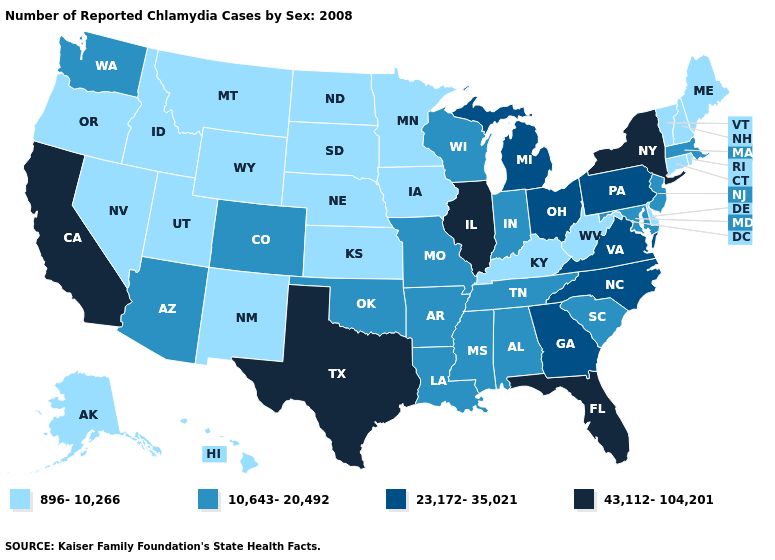What is the value of Nebraska?
Short answer required. 896-10,266. Among the states that border Louisiana , which have the highest value?
Write a very short answer. Texas. Name the states that have a value in the range 43,112-104,201?
Give a very brief answer. California, Florida, Illinois, New York, Texas. Is the legend a continuous bar?
Answer briefly. No. Among the states that border Colorado , which have the lowest value?
Quick response, please. Kansas, Nebraska, New Mexico, Utah, Wyoming. Name the states that have a value in the range 896-10,266?
Give a very brief answer. Alaska, Connecticut, Delaware, Hawaii, Idaho, Iowa, Kansas, Kentucky, Maine, Minnesota, Montana, Nebraska, Nevada, New Hampshire, New Mexico, North Dakota, Oregon, Rhode Island, South Dakota, Utah, Vermont, West Virginia, Wyoming. Does Florida have the highest value in the USA?
Give a very brief answer. Yes. What is the lowest value in the Northeast?
Quick response, please. 896-10,266. What is the highest value in states that border Vermont?
Keep it brief. 43,112-104,201. Name the states that have a value in the range 10,643-20,492?
Keep it brief. Alabama, Arizona, Arkansas, Colorado, Indiana, Louisiana, Maryland, Massachusetts, Mississippi, Missouri, New Jersey, Oklahoma, South Carolina, Tennessee, Washington, Wisconsin. Name the states that have a value in the range 23,172-35,021?
Concise answer only. Georgia, Michigan, North Carolina, Ohio, Pennsylvania, Virginia. What is the value of Oregon?
Answer briefly. 896-10,266. What is the highest value in states that border New York?
Be succinct. 23,172-35,021. What is the value of Rhode Island?
Give a very brief answer. 896-10,266. Does Florida have the same value as California?
Give a very brief answer. Yes. 